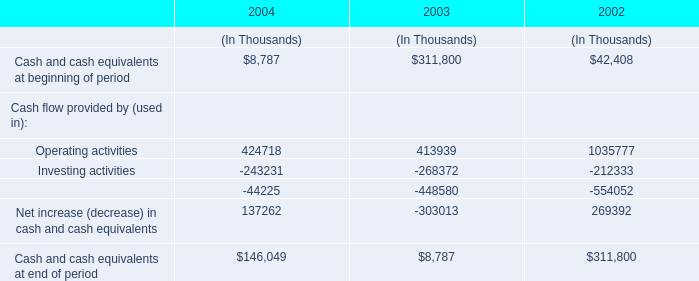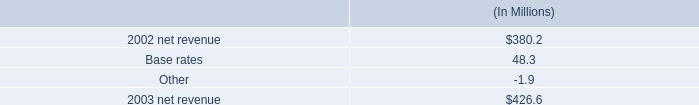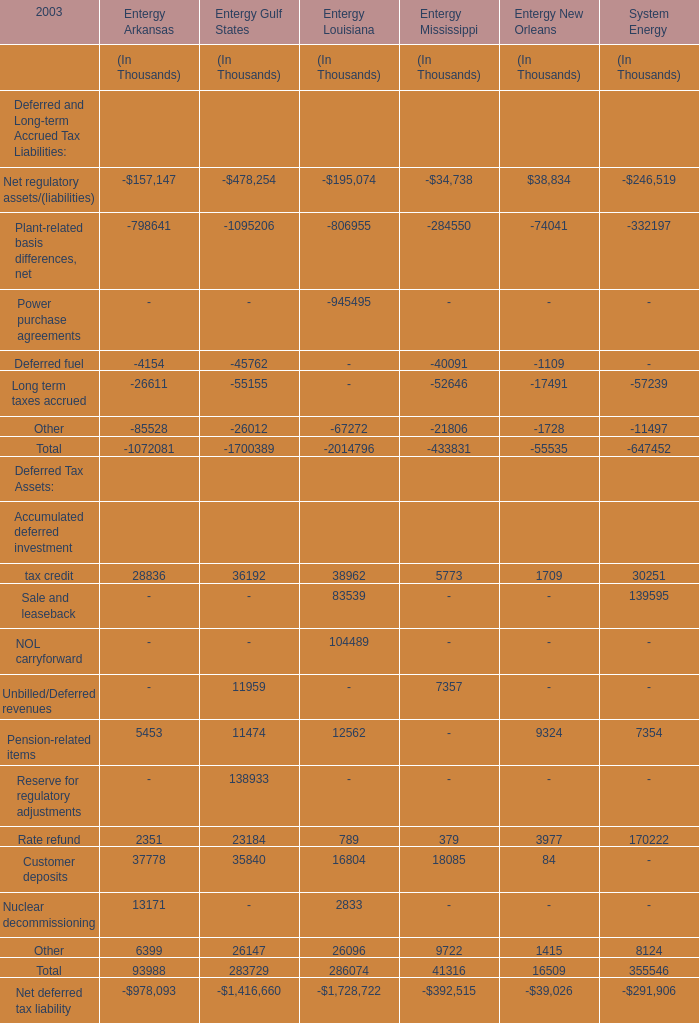what is the growth rate in net revenue for entergy mississippi , inc . in 2003? 
Computations: ((426.6 - 380.2) / 380.2)
Answer: 0.12204. 